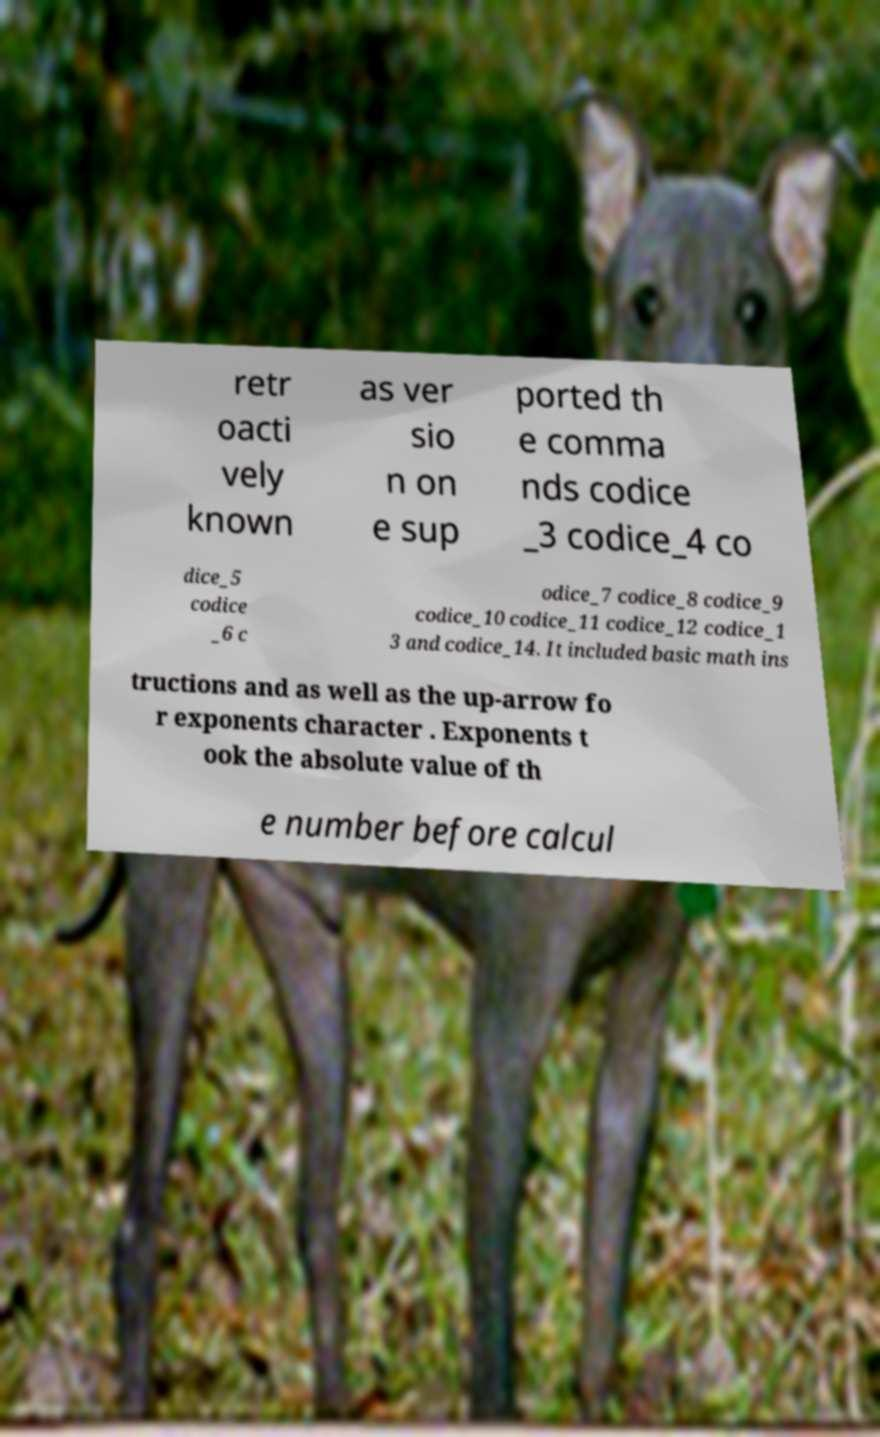Please read and relay the text visible in this image. What does it say? retr oacti vely known as ver sio n on e sup ported th e comma nds codice _3 codice_4 co dice_5 codice _6 c odice_7 codice_8 codice_9 codice_10 codice_11 codice_12 codice_1 3 and codice_14. It included basic math ins tructions and as well as the up-arrow fo r exponents character . Exponents t ook the absolute value of th e number before calcul 